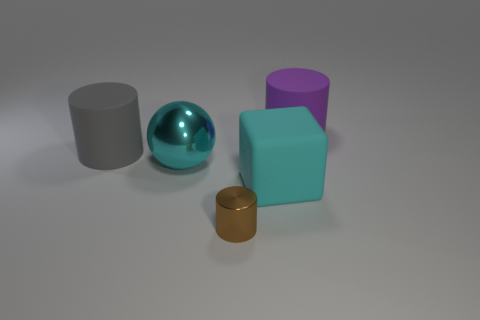What number of objects are large things that are to the left of the big purple matte cylinder or large rubber cylinders right of the big cube?
Offer a terse response. 4. Are there the same number of matte things that are in front of the small brown shiny cylinder and spheres?
Your answer should be compact. No. Does the metallic thing on the left side of the small brown shiny thing have the same size as the matte cylinder on the left side of the big purple cylinder?
Provide a short and direct response. Yes. What number of other objects are the same size as the cyan shiny object?
Keep it short and to the point. 3. Is there a big gray rubber object that is in front of the big cylinder left of the cylinder to the right of the metallic cylinder?
Your answer should be compact. No. Is there any other thing of the same color as the big metal ball?
Your response must be concise. Yes. There is a rubber thing that is left of the big shiny object; what size is it?
Provide a short and direct response. Large. There is a purple rubber thing that is behind the big cylinder that is in front of the rubber cylinder to the right of the big cyan rubber cube; how big is it?
Offer a terse response. Large. The large cylinder right of the big object that is on the left side of the large metallic thing is what color?
Your response must be concise. Purple. There is a brown object that is the same shape as the large gray rubber object; what is it made of?
Your answer should be very brief. Metal. 